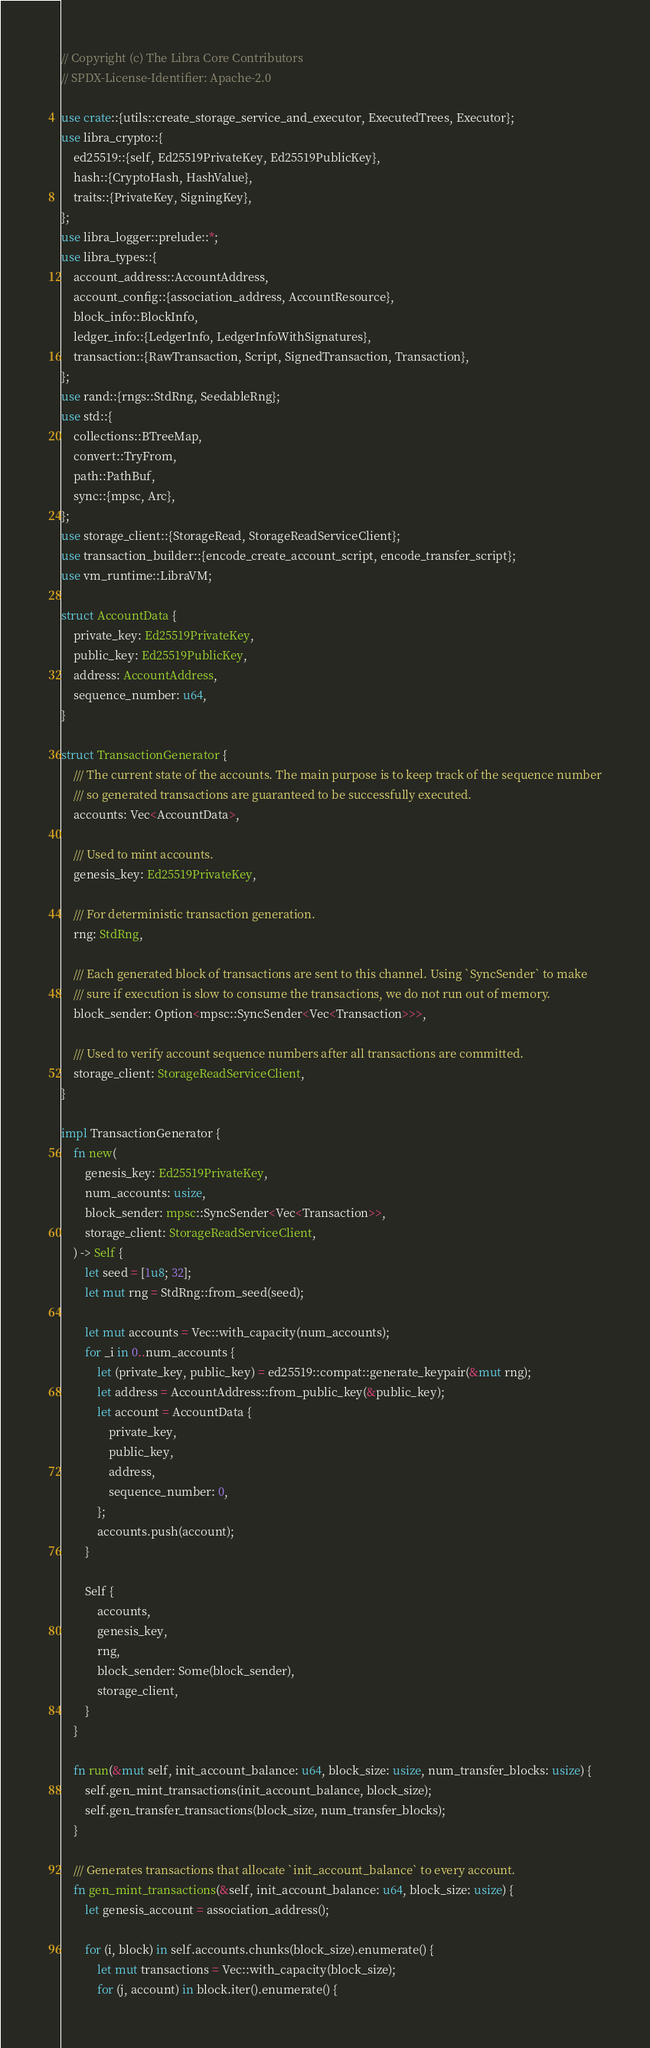<code> <loc_0><loc_0><loc_500><loc_500><_Rust_>// Copyright (c) The Libra Core Contributors
// SPDX-License-Identifier: Apache-2.0

use crate::{utils::create_storage_service_and_executor, ExecutedTrees, Executor};
use libra_crypto::{
    ed25519::{self, Ed25519PrivateKey, Ed25519PublicKey},
    hash::{CryptoHash, HashValue},
    traits::{PrivateKey, SigningKey},
};
use libra_logger::prelude::*;
use libra_types::{
    account_address::AccountAddress,
    account_config::{association_address, AccountResource},
    block_info::BlockInfo,
    ledger_info::{LedgerInfo, LedgerInfoWithSignatures},
    transaction::{RawTransaction, Script, SignedTransaction, Transaction},
};
use rand::{rngs::StdRng, SeedableRng};
use std::{
    collections::BTreeMap,
    convert::TryFrom,
    path::PathBuf,
    sync::{mpsc, Arc},
};
use storage_client::{StorageRead, StorageReadServiceClient};
use transaction_builder::{encode_create_account_script, encode_transfer_script};
use vm_runtime::LibraVM;

struct AccountData {
    private_key: Ed25519PrivateKey,
    public_key: Ed25519PublicKey,
    address: AccountAddress,
    sequence_number: u64,
}

struct TransactionGenerator {
    /// The current state of the accounts. The main purpose is to keep track of the sequence number
    /// so generated transactions are guaranteed to be successfully executed.
    accounts: Vec<AccountData>,

    /// Used to mint accounts.
    genesis_key: Ed25519PrivateKey,

    /// For deterministic transaction generation.
    rng: StdRng,

    /// Each generated block of transactions are sent to this channel. Using `SyncSender` to make
    /// sure if execution is slow to consume the transactions, we do not run out of memory.
    block_sender: Option<mpsc::SyncSender<Vec<Transaction>>>,

    /// Used to verify account sequence numbers after all transactions are committed.
    storage_client: StorageReadServiceClient,
}

impl TransactionGenerator {
    fn new(
        genesis_key: Ed25519PrivateKey,
        num_accounts: usize,
        block_sender: mpsc::SyncSender<Vec<Transaction>>,
        storage_client: StorageReadServiceClient,
    ) -> Self {
        let seed = [1u8; 32];
        let mut rng = StdRng::from_seed(seed);

        let mut accounts = Vec::with_capacity(num_accounts);
        for _i in 0..num_accounts {
            let (private_key, public_key) = ed25519::compat::generate_keypair(&mut rng);
            let address = AccountAddress::from_public_key(&public_key);
            let account = AccountData {
                private_key,
                public_key,
                address,
                sequence_number: 0,
            };
            accounts.push(account);
        }

        Self {
            accounts,
            genesis_key,
            rng,
            block_sender: Some(block_sender),
            storage_client,
        }
    }

    fn run(&mut self, init_account_balance: u64, block_size: usize, num_transfer_blocks: usize) {
        self.gen_mint_transactions(init_account_balance, block_size);
        self.gen_transfer_transactions(block_size, num_transfer_blocks);
    }

    /// Generates transactions that allocate `init_account_balance` to every account.
    fn gen_mint_transactions(&self, init_account_balance: u64, block_size: usize) {
        let genesis_account = association_address();

        for (i, block) in self.accounts.chunks(block_size).enumerate() {
            let mut transactions = Vec::with_capacity(block_size);
            for (j, account) in block.iter().enumerate() {</code> 